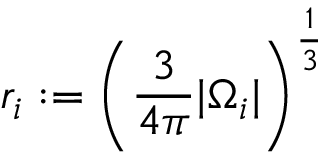Convert formula to latex. <formula><loc_0><loc_0><loc_500><loc_500>r _ { i } \colon = \left ( \frac { 3 } { 4 \pi } | \Omega _ { i } | \right ) ^ { \frac { 1 } { 3 } }</formula> 